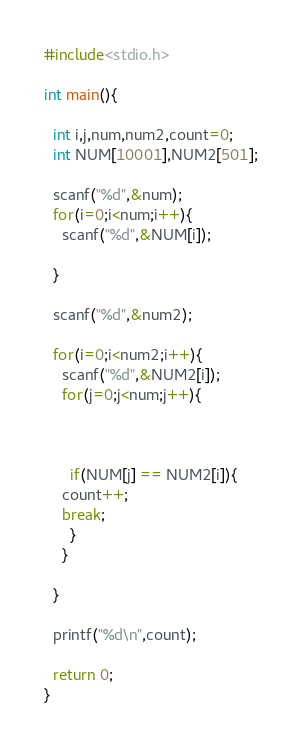<code> <loc_0><loc_0><loc_500><loc_500><_C_>#include<stdio.h>

int main(){
  
  int i,j,num,num2,count=0;
  int NUM[10001],NUM2[501];
  
  scanf("%d",&num);
  for(i=0;i<num;i++){
    scanf("%d",&NUM[i]);
    
  }
  
  scanf("%d",&num2);
  
  for(i=0;i<num2;i++){
    scanf("%d",&NUM2[i]);
    for(j=0;j<num;j++){
      
   
      
      if(NUM[j] == NUM2[i]){
	count++;
	break;
      }
    }
    
  }
  
  printf("%d\n",count);
  
  return 0;
}</code> 